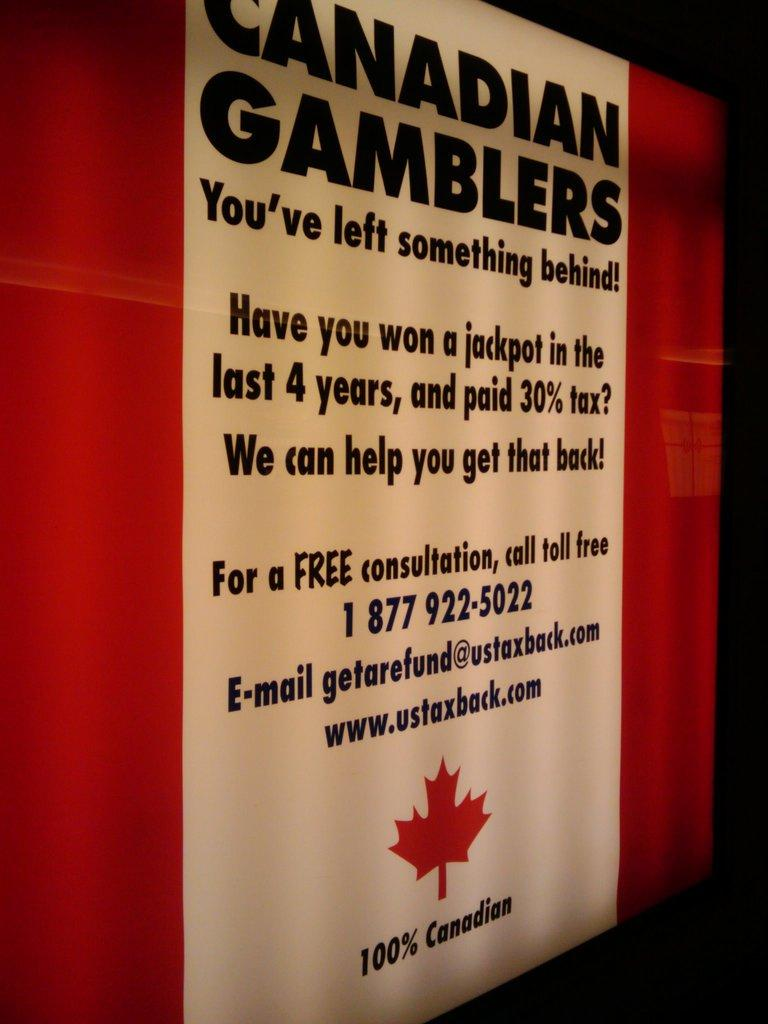<image>
Describe the image concisely. A sign that says "Canadian Gamblers You've left something behind!" and includes information about a free tax consultation is shown. 